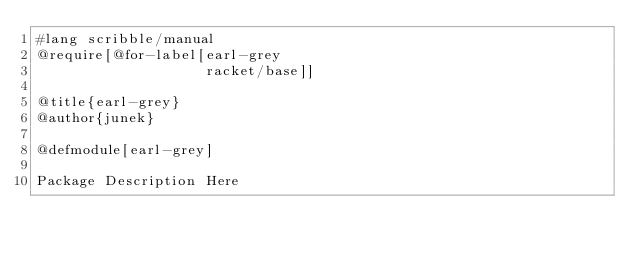Convert code to text. <code><loc_0><loc_0><loc_500><loc_500><_Racket_>#lang scribble/manual
@require[@for-label[earl-grey
                    racket/base]]

@title{earl-grey}
@author{junek}

@defmodule[earl-grey]

Package Description Here

</code> 